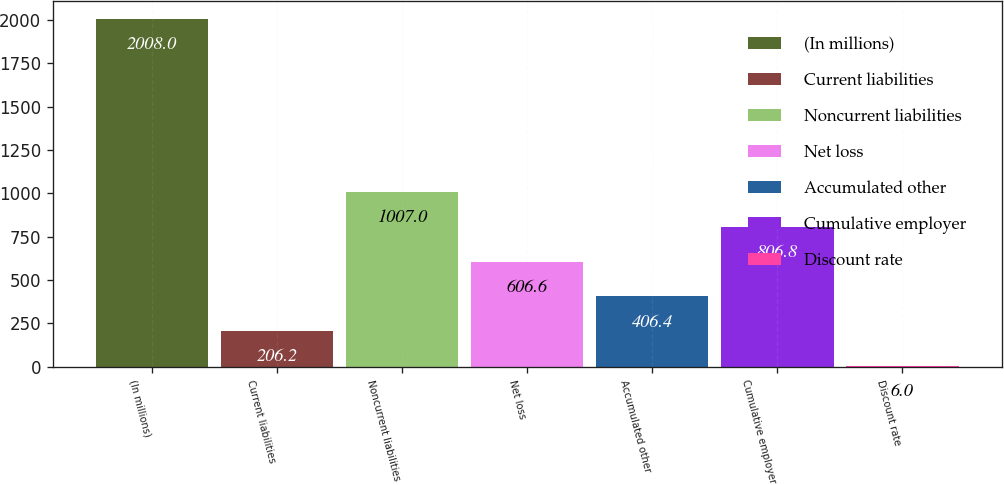Convert chart to OTSL. <chart><loc_0><loc_0><loc_500><loc_500><bar_chart><fcel>(In millions)<fcel>Current liabilities<fcel>Noncurrent liabilities<fcel>Net loss<fcel>Accumulated other<fcel>Cumulative employer<fcel>Discount rate<nl><fcel>2008<fcel>206.2<fcel>1007<fcel>606.6<fcel>406.4<fcel>806.8<fcel>6<nl></chart> 